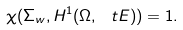<formula> <loc_0><loc_0><loc_500><loc_500>\chi ( \Sigma _ { w } , H ^ { 1 } ( \Omega , \ t E ) ) = 1 .</formula> 